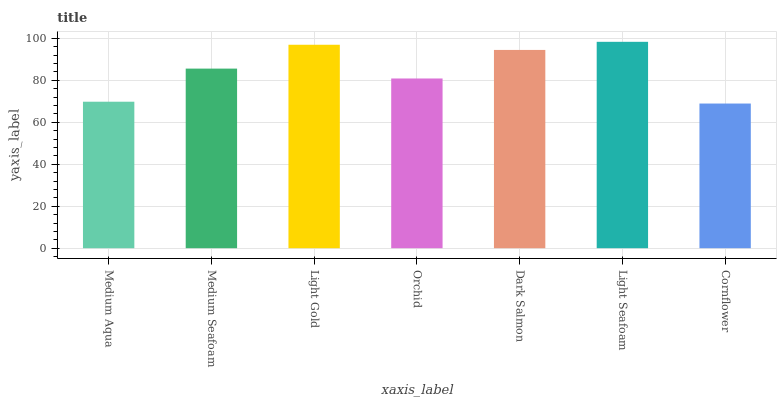Is Medium Seafoam the minimum?
Answer yes or no. No. Is Medium Seafoam the maximum?
Answer yes or no. No. Is Medium Seafoam greater than Medium Aqua?
Answer yes or no. Yes. Is Medium Aqua less than Medium Seafoam?
Answer yes or no. Yes. Is Medium Aqua greater than Medium Seafoam?
Answer yes or no. No. Is Medium Seafoam less than Medium Aqua?
Answer yes or no. No. Is Medium Seafoam the high median?
Answer yes or no. Yes. Is Medium Seafoam the low median?
Answer yes or no. Yes. Is Light Gold the high median?
Answer yes or no. No. Is Orchid the low median?
Answer yes or no. No. 